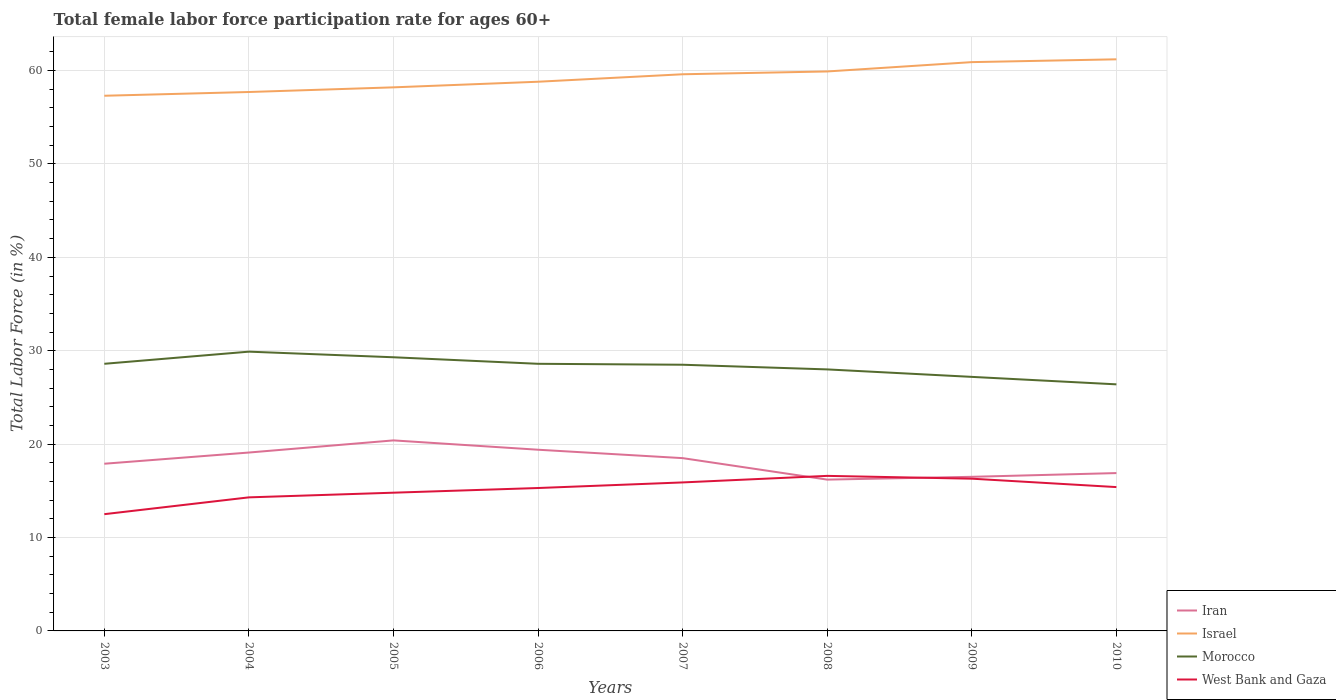How many different coloured lines are there?
Offer a very short reply. 4. Across all years, what is the maximum female labor force participation rate in Iran?
Your response must be concise. 16.2. In which year was the female labor force participation rate in Iran maximum?
Ensure brevity in your answer.  2008. What is the difference between the highest and the second highest female labor force participation rate in Iran?
Offer a terse response. 4.2. What is the difference between the highest and the lowest female labor force participation rate in Israel?
Your response must be concise. 4. Is the female labor force participation rate in Iran strictly greater than the female labor force participation rate in Israel over the years?
Your answer should be very brief. Yes. How many years are there in the graph?
Make the answer very short. 8. What is the difference between two consecutive major ticks on the Y-axis?
Offer a terse response. 10. Does the graph contain any zero values?
Your response must be concise. No. Does the graph contain grids?
Offer a terse response. Yes. Where does the legend appear in the graph?
Provide a short and direct response. Bottom right. How are the legend labels stacked?
Your response must be concise. Vertical. What is the title of the graph?
Keep it short and to the point. Total female labor force participation rate for ages 60+. What is the label or title of the Y-axis?
Your answer should be compact. Total Labor Force (in %). What is the Total Labor Force (in %) of Iran in 2003?
Your response must be concise. 17.9. What is the Total Labor Force (in %) in Israel in 2003?
Your answer should be compact. 57.3. What is the Total Labor Force (in %) in Morocco in 2003?
Your response must be concise. 28.6. What is the Total Labor Force (in %) of West Bank and Gaza in 2003?
Ensure brevity in your answer.  12.5. What is the Total Labor Force (in %) in Iran in 2004?
Your answer should be compact. 19.1. What is the Total Labor Force (in %) of Israel in 2004?
Ensure brevity in your answer.  57.7. What is the Total Labor Force (in %) of Morocco in 2004?
Your answer should be very brief. 29.9. What is the Total Labor Force (in %) in West Bank and Gaza in 2004?
Make the answer very short. 14.3. What is the Total Labor Force (in %) of Iran in 2005?
Ensure brevity in your answer.  20.4. What is the Total Labor Force (in %) of Israel in 2005?
Give a very brief answer. 58.2. What is the Total Labor Force (in %) of Morocco in 2005?
Make the answer very short. 29.3. What is the Total Labor Force (in %) of West Bank and Gaza in 2005?
Make the answer very short. 14.8. What is the Total Labor Force (in %) in Iran in 2006?
Ensure brevity in your answer.  19.4. What is the Total Labor Force (in %) of Israel in 2006?
Your response must be concise. 58.8. What is the Total Labor Force (in %) of Morocco in 2006?
Your answer should be very brief. 28.6. What is the Total Labor Force (in %) in West Bank and Gaza in 2006?
Your answer should be very brief. 15.3. What is the Total Labor Force (in %) in Iran in 2007?
Offer a very short reply. 18.5. What is the Total Labor Force (in %) in Israel in 2007?
Make the answer very short. 59.6. What is the Total Labor Force (in %) of Morocco in 2007?
Provide a succinct answer. 28.5. What is the Total Labor Force (in %) of West Bank and Gaza in 2007?
Your response must be concise. 15.9. What is the Total Labor Force (in %) in Iran in 2008?
Your response must be concise. 16.2. What is the Total Labor Force (in %) of Israel in 2008?
Your answer should be compact. 59.9. What is the Total Labor Force (in %) in Morocco in 2008?
Keep it short and to the point. 28. What is the Total Labor Force (in %) in West Bank and Gaza in 2008?
Offer a terse response. 16.6. What is the Total Labor Force (in %) of Iran in 2009?
Provide a short and direct response. 16.5. What is the Total Labor Force (in %) of Israel in 2009?
Offer a very short reply. 60.9. What is the Total Labor Force (in %) in Morocco in 2009?
Your answer should be compact. 27.2. What is the Total Labor Force (in %) in West Bank and Gaza in 2009?
Make the answer very short. 16.3. What is the Total Labor Force (in %) in Iran in 2010?
Offer a very short reply. 16.9. What is the Total Labor Force (in %) of Israel in 2010?
Keep it short and to the point. 61.2. What is the Total Labor Force (in %) in Morocco in 2010?
Offer a very short reply. 26.4. What is the Total Labor Force (in %) of West Bank and Gaza in 2010?
Offer a terse response. 15.4. Across all years, what is the maximum Total Labor Force (in %) of Iran?
Provide a succinct answer. 20.4. Across all years, what is the maximum Total Labor Force (in %) of Israel?
Your response must be concise. 61.2. Across all years, what is the maximum Total Labor Force (in %) in Morocco?
Keep it short and to the point. 29.9. Across all years, what is the maximum Total Labor Force (in %) in West Bank and Gaza?
Your response must be concise. 16.6. Across all years, what is the minimum Total Labor Force (in %) of Iran?
Make the answer very short. 16.2. Across all years, what is the minimum Total Labor Force (in %) in Israel?
Offer a very short reply. 57.3. Across all years, what is the minimum Total Labor Force (in %) of Morocco?
Give a very brief answer. 26.4. Across all years, what is the minimum Total Labor Force (in %) of West Bank and Gaza?
Keep it short and to the point. 12.5. What is the total Total Labor Force (in %) of Iran in the graph?
Keep it short and to the point. 144.9. What is the total Total Labor Force (in %) of Israel in the graph?
Ensure brevity in your answer.  473.6. What is the total Total Labor Force (in %) of Morocco in the graph?
Provide a succinct answer. 226.5. What is the total Total Labor Force (in %) of West Bank and Gaza in the graph?
Provide a succinct answer. 121.1. What is the difference between the Total Labor Force (in %) of Morocco in 2003 and that in 2004?
Provide a succinct answer. -1.3. What is the difference between the Total Labor Force (in %) of West Bank and Gaza in 2003 and that in 2004?
Provide a succinct answer. -1.8. What is the difference between the Total Labor Force (in %) in Iran in 2003 and that in 2005?
Provide a succinct answer. -2.5. What is the difference between the Total Labor Force (in %) of Morocco in 2003 and that in 2005?
Give a very brief answer. -0.7. What is the difference between the Total Labor Force (in %) in West Bank and Gaza in 2003 and that in 2005?
Your response must be concise. -2.3. What is the difference between the Total Labor Force (in %) in Iran in 2003 and that in 2006?
Offer a terse response. -1.5. What is the difference between the Total Labor Force (in %) of Israel in 2003 and that in 2006?
Ensure brevity in your answer.  -1.5. What is the difference between the Total Labor Force (in %) in Israel in 2003 and that in 2007?
Your answer should be compact. -2.3. What is the difference between the Total Labor Force (in %) of Morocco in 2003 and that in 2007?
Your response must be concise. 0.1. What is the difference between the Total Labor Force (in %) of West Bank and Gaza in 2003 and that in 2007?
Offer a very short reply. -3.4. What is the difference between the Total Labor Force (in %) of Iran in 2003 and that in 2008?
Provide a short and direct response. 1.7. What is the difference between the Total Labor Force (in %) of Morocco in 2003 and that in 2008?
Provide a succinct answer. 0.6. What is the difference between the Total Labor Force (in %) of Iran in 2003 and that in 2009?
Make the answer very short. 1.4. What is the difference between the Total Labor Force (in %) in Israel in 2003 and that in 2010?
Make the answer very short. -3.9. What is the difference between the Total Labor Force (in %) in West Bank and Gaza in 2003 and that in 2010?
Offer a very short reply. -2.9. What is the difference between the Total Labor Force (in %) of Iran in 2004 and that in 2005?
Your answer should be very brief. -1.3. What is the difference between the Total Labor Force (in %) in Israel in 2004 and that in 2005?
Provide a succinct answer. -0.5. What is the difference between the Total Labor Force (in %) in Morocco in 2004 and that in 2005?
Your response must be concise. 0.6. What is the difference between the Total Labor Force (in %) in West Bank and Gaza in 2004 and that in 2005?
Provide a succinct answer. -0.5. What is the difference between the Total Labor Force (in %) in Israel in 2004 and that in 2006?
Provide a succinct answer. -1.1. What is the difference between the Total Labor Force (in %) in Morocco in 2004 and that in 2006?
Your answer should be compact. 1.3. What is the difference between the Total Labor Force (in %) in West Bank and Gaza in 2004 and that in 2006?
Give a very brief answer. -1. What is the difference between the Total Labor Force (in %) of Iran in 2004 and that in 2007?
Keep it short and to the point. 0.6. What is the difference between the Total Labor Force (in %) in West Bank and Gaza in 2004 and that in 2008?
Offer a very short reply. -2.3. What is the difference between the Total Labor Force (in %) of Iran in 2004 and that in 2009?
Offer a very short reply. 2.6. What is the difference between the Total Labor Force (in %) in Israel in 2004 and that in 2009?
Ensure brevity in your answer.  -3.2. What is the difference between the Total Labor Force (in %) in West Bank and Gaza in 2004 and that in 2009?
Your response must be concise. -2. What is the difference between the Total Labor Force (in %) of Morocco in 2004 and that in 2010?
Offer a very short reply. 3.5. What is the difference between the Total Labor Force (in %) of Iran in 2005 and that in 2006?
Give a very brief answer. 1. What is the difference between the Total Labor Force (in %) in Morocco in 2005 and that in 2006?
Make the answer very short. 0.7. What is the difference between the Total Labor Force (in %) of West Bank and Gaza in 2005 and that in 2006?
Give a very brief answer. -0.5. What is the difference between the Total Labor Force (in %) of Iran in 2005 and that in 2007?
Make the answer very short. 1.9. What is the difference between the Total Labor Force (in %) in Morocco in 2005 and that in 2007?
Keep it short and to the point. 0.8. What is the difference between the Total Labor Force (in %) in Iran in 2005 and that in 2008?
Keep it short and to the point. 4.2. What is the difference between the Total Labor Force (in %) of Israel in 2005 and that in 2008?
Ensure brevity in your answer.  -1.7. What is the difference between the Total Labor Force (in %) of Iran in 2005 and that in 2009?
Make the answer very short. 3.9. What is the difference between the Total Labor Force (in %) of Israel in 2005 and that in 2009?
Offer a terse response. -2.7. What is the difference between the Total Labor Force (in %) in Morocco in 2005 and that in 2009?
Give a very brief answer. 2.1. What is the difference between the Total Labor Force (in %) of West Bank and Gaza in 2005 and that in 2009?
Your answer should be very brief. -1.5. What is the difference between the Total Labor Force (in %) in Morocco in 2005 and that in 2010?
Your response must be concise. 2.9. What is the difference between the Total Labor Force (in %) in West Bank and Gaza in 2005 and that in 2010?
Offer a very short reply. -0.6. What is the difference between the Total Labor Force (in %) of Israel in 2006 and that in 2007?
Keep it short and to the point. -0.8. What is the difference between the Total Labor Force (in %) in Iran in 2006 and that in 2008?
Provide a succinct answer. 3.2. What is the difference between the Total Labor Force (in %) of Morocco in 2006 and that in 2008?
Your answer should be compact. 0.6. What is the difference between the Total Labor Force (in %) in Israel in 2006 and that in 2009?
Make the answer very short. -2.1. What is the difference between the Total Labor Force (in %) in Morocco in 2006 and that in 2009?
Your answer should be very brief. 1.4. What is the difference between the Total Labor Force (in %) in Iran in 2006 and that in 2010?
Provide a succinct answer. 2.5. What is the difference between the Total Labor Force (in %) of Israel in 2006 and that in 2010?
Your response must be concise. -2.4. What is the difference between the Total Labor Force (in %) of Iran in 2007 and that in 2008?
Provide a succinct answer. 2.3. What is the difference between the Total Labor Force (in %) of West Bank and Gaza in 2007 and that in 2009?
Keep it short and to the point. -0.4. What is the difference between the Total Labor Force (in %) of Israel in 2007 and that in 2010?
Provide a succinct answer. -1.6. What is the difference between the Total Labor Force (in %) in Iran in 2008 and that in 2009?
Offer a very short reply. -0.3. What is the difference between the Total Labor Force (in %) of Israel in 2008 and that in 2009?
Keep it short and to the point. -1. What is the difference between the Total Labor Force (in %) of Morocco in 2008 and that in 2009?
Provide a succinct answer. 0.8. What is the difference between the Total Labor Force (in %) in Iran in 2008 and that in 2010?
Offer a terse response. -0.7. What is the difference between the Total Labor Force (in %) of West Bank and Gaza in 2008 and that in 2010?
Provide a succinct answer. 1.2. What is the difference between the Total Labor Force (in %) of Iran in 2009 and that in 2010?
Ensure brevity in your answer.  -0.4. What is the difference between the Total Labor Force (in %) of Morocco in 2009 and that in 2010?
Your answer should be very brief. 0.8. What is the difference between the Total Labor Force (in %) in Iran in 2003 and the Total Labor Force (in %) in Israel in 2004?
Make the answer very short. -39.8. What is the difference between the Total Labor Force (in %) of Israel in 2003 and the Total Labor Force (in %) of Morocco in 2004?
Your answer should be very brief. 27.4. What is the difference between the Total Labor Force (in %) in Morocco in 2003 and the Total Labor Force (in %) in West Bank and Gaza in 2004?
Make the answer very short. 14.3. What is the difference between the Total Labor Force (in %) of Iran in 2003 and the Total Labor Force (in %) of Israel in 2005?
Provide a short and direct response. -40.3. What is the difference between the Total Labor Force (in %) in Iran in 2003 and the Total Labor Force (in %) in Morocco in 2005?
Offer a very short reply. -11.4. What is the difference between the Total Labor Force (in %) in Iran in 2003 and the Total Labor Force (in %) in West Bank and Gaza in 2005?
Your answer should be compact. 3.1. What is the difference between the Total Labor Force (in %) of Israel in 2003 and the Total Labor Force (in %) of West Bank and Gaza in 2005?
Ensure brevity in your answer.  42.5. What is the difference between the Total Labor Force (in %) of Morocco in 2003 and the Total Labor Force (in %) of West Bank and Gaza in 2005?
Offer a very short reply. 13.8. What is the difference between the Total Labor Force (in %) of Iran in 2003 and the Total Labor Force (in %) of Israel in 2006?
Ensure brevity in your answer.  -40.9. What is the difference between the Total Labor Force (in %) of Iran in 2003 and the Total Labor Force (in %) of Morocco in 2006?
Your answer should be very brief. -10.7. What is the difference between the Total Labor Force (in %) in Iran in 2003 and the Total Labor Force (in %) in West Bank and Gaza in 2006?
Make the answer very short. 2.6. What is the difference between the Total Labor Force (in %) of Israel in 2003 and the Total Labor Force (in %) of Morocco in 2006?
Your answer should be very brief. 28.7. What is the difference between the Total Labor Force (in %) in Morocco in 2003 and the Total Labor Force (in %) in West Bank and Gaza in 2006?
Ensure brevity in your answer.  13.3. What is the difference between the Total Labor Force (in %) of Iran in 2003 and the Total Labor Force (in %) of Israel in 2007?
Your answer should be compact. -41.7. What is the difference between the Total Labor Force (in %) of Israel in 2003 and the Total Labor Force (in %) of Morocco in 2007?
Provide a succinct answer. 28.8. What is the difference between the Total Labor Force (in %) in Israel in 2003 and the Total Labor Force (in %) in West Bank and Gaza in 2007?
Give a very brief answer. 41.4. What is the difference between the Total Labor Force (in %) of Iran in 2003 and the Total Labor Force (in %) of Israel in 2008?
Provide a succinct answer. -42. What is the difference between the Total Labor Force (in %) of Iran in 2003 and the Total Labor Force (in %) of West Bank and Gaza in 2008?
Provide a short and direct response. 1.3. What is the difference between the Total Labor Force (in %) in Israel in 2003 and the Total Labor Force (in %) in Morocco in 2008?
Ensure brevity in your answer.  29.3. What is the difference between the Total Labor Force (in %) of Israel in 2003 and the Total Labor Force (in %) of West Bank and Gaza in 2008?
Your answer should be compact. 40.7. What is the difference between the Total Labor Force (in %) in Morocco in 2003 and the Total Labor Force (in %) in West Bank and Gaza in 2008?
Your answer should be very brief. 12. What is the difference between the Total Labor Force (in %) in Iran in 2003 and the Total Labor Force (in %) in Israel in 2009?
Give a very brief answer. -43. What is the difference between the Total Labor Force (in %) in Iran in 2003 and the Total Labor Force (in %) in Morocco in 2009?
Offer a very short reply. -9.3. What is the difference between the Total Labor Force (in %) in Israel in 2003 and the Total Labor Force (in %) in Morocco in 2009?
Keep it short and to the point. 30.1. What is the difference between the Total Labor Force (in %) of Morocco in 2003 and the Total Labor Force (in %) of West Bank and Gaza in 2009?
Provide a succinct answer. 12.3. What is the difference between the Total Labor Force (in %) of Iran in 2003 and the Total Labor Force (in %) of Israel in 2010?
Give a very brief answer. -43.3. What is the difference between the Total Labor Force (in %) in Iran in 2003 and the Total Labor Force (in %) in West Bank and Gaza in 2010?
Provide a short and direct response. 2.5. What is the difference between the Total Labor Force (in %) of Israel in 2003 and the Total Labor Force (in %) of Morocco in 2010?
Your answer should be very brief. 30.9. What is the difference between the Total Labor Force (in %) in Israel in 2003 and the Total Labor Force (in %) in West Bank and Gaza in 2010?
Ensure brevity in your answer.  41.9. What is the difference between the Total Labor Force (in %) of Morocco in 2003 and the Total Labor Force (in %) of West Bank and Gaza in 2010?
Your answer should be compact. 13.2. What is the difference between the Total Labor Force (in %) of Iran in 2004 and the Total Labor Force (in %) of Israel in 2005?
Offer a very short reply. -39.1. What is the difference between the Total Labor Force (in %) of Iran in 2004 and the Total Labor Force (in %) of West Bank and Gaza in 2005?
Ensure brevity in your answer.  4.3. What is the difference between the Total Labor Force (in %) of Israel in 2004 and the Total Labor Force (in %) of Morocco in 2005?
Provide a succinct answer. 28.4. What is the difference between the Total Labor Force (in %) in Israel in 2004 and the Total Labor Force (in %) in West Bank and Gaza in 2005?
Keep it short and to the point. 42.9. What is the difference between the Total Labor Force (in %) of Morocco in 2004 and the Total Labor Force (in %) of West Bank and Gaza in 2005?
Keep it short and to the point. 15.1. What is the difference between the Total Labor Force (in %) in Iran in 2004 and the Total Labor Force (in %) in Israel in 2006?
Keep it short and to the point. -39.7. What is the difference between the Total Labor Force (in %) in Iran in 2004 and the Total Labor Force (in %) in Morocco in 2006?
Ensure brevity in your answer.  -9.5. What is the difference between the Total Labor Force (in %) of Israel in 2004 and the Total Labor Force (in %) of Morocco in 2006?
Your answer should be compact. 29.1. What is the difference between the Total Labor Force (in %) in Israel in 2004 and the Total Labor Force (in %) in West Bank and Gaza in 2006?
Your answer should be compact. 42.4. What is the difference between the Total Labor Force (in %) in Morocco in 2004 and the Total Labor Force (in %) in West Bank and Gaza in 2006?
Offer a terse response. 14.6. What is the difference between the Total Labor Force (in %) in Iran in 2004 and the Total Labor Force (in %) in Israel in 2007?
Offer a very short reply. -40.5. What is the difference between the Total Labor Force (in %) of Iran in 2004 and the Total Labor Force (in %) of West Bank and Gaza in 2007?
Offer a very short reply. 3.2. What is the difference between the Total Labor Force (in %) in Israel in 2004 and the Total Labor Force (in %) in Morocco in 2007?
Your answer should be compact. 29.2. What is the difference between the Total Labor Force (in %) of Israel in 2004 and the Total Labor Force (in %) of West Bank and Gaza in 2007?
Make the answer very short. 41.8. What is the difference between the Total Labor Force (in %) of Morocco in 2004 and the Total Labor Force (in %) of West Bank and Gaza in 2007?
Offer a very short reply. 14. What is the difference between the Total Labor Force (in %) in Iran in 2004 and the Total Labor Force (in %) in Israel in 2008?
Your answer should be very brief. -40.8. What is the difference between the Total Labor Force (in %) in Iran in 2004 and the Total Labor Force (in %) in Morocco in 2008?
Keep it short and to the point. -8.9. What is the difference between the Total Labor Force (in %) of Israel in 2004 and the Total Labor Force (in %) of Morocco in 2008?
Offer a very short reply. 29.7. What is the difference between the Total Labor Force (in %) in Israel in 2004 and the Total Labor Force (in %) in West Bank and Gaza in 2008?
Give a very brief answer. 41.1. What is the difference between the Total Labor Force (in %) of Morocco in 2004 and the Total Labor Force (in %) of West Bank and Gaza in 2008?
Offer a very short reply. 13.3. What is the difference between the Total Labor Force (in %) of Iran in 2004 and the Total Labor Force (in %) of Israel in 2009?
Your response must be concise. -41.8. What is the difference between the Total Labor Force (in %) in Iran in 2004 and the Total Labor Force (in %) in Morocco in 2009?
Your answer should be very brief. -8.1. What is the difference between the Total Labor Force (in %) in Israel in 2004 and the Total Labor Force (in %) in Morocco in 2009?
Your answer should be very brief. 30.5. What is the difference between the Total Labor Force (in %) of Israel in 2004 and the Total Labor Force (in %) of West Bank and Gaza in 2009?
Offer a terse response. 41.4. What is the difference between the Total Labor Force (in %) of Morocco in 2004 and the Total Labor Force (in %) of West Bank and Gaza in 2009?
Provide a short and direct response. 13.6. What is the difference between the Total Labor Force (in %) in Iran in 2004 and the Total Labor Force (in %) in Israel in 2010?
Your response must be concise. -42.1. What is the difference between the Total Labor Force (in %) in Iran in 2004 and the Total Labor Force (in %) in Morocco in 2010?
Offer a very short reply. -7.3. What is the difference between the Total Labor Force (in %) of Iran in 2004 and the Total Labor Force (in %) of West Bank and Gaza in 2010?
Provide a succinct answer. 3.7. What is the difference between the Total Labor Force (in %) in Israel in 2004 and the Total Labor Force (in %) in Morocco in 2010?
Keep it short and to the point. 31.3. What is the difference between the Total Labor Force (in %) of Israel in 2004 and the Total Labor Force (in %) of West Bank and Gaza in 2010?
Ensure brevity in your answer.  42.3. What is the difference between the Total Labor Force (in %) of Morocco in 2004 and the Total Labor Force (in %) of West Bank and Gaza in 2010?
Offer a terse response. 14.5. What is the difference between the Total Labor Force (in %) of Iran in 2005 and the Total Labor Force (in %) of Israel in 2006?
Your answer should be compact. -38.4. What is the difference between the Total Labor Force (in %) of Iran in 2005 and the Total Labor Force (in %) of Morocco in 2006?
Provide a succinct answer. -8.2. What is the difference between the Total Labor Force (in %) in Iran in 2005 and the Total Labor Force (in %) in West Bank and Gaza in 2006?
Offer a terse response. 5.1. What is the difference between the Total Labor Force (in %) of Israel in 2005 and the Total Labor Force (in %) of Morocco in 2006?
Give a very brief answer. 29.6. What is the difference between the Total Labor Force (in %) in Israel in 2005 and the Total Labor Force (in %) in West Bank and Gaza in 2006?
Offer a very short reply. 42.9. What is the difference between the Total Labor Force (in %) in Morocco in 2005 and the Total Labor Force (in %) in West Bank and Gaza in 2006?
Provide a succinct answer. 14. What is the difference between the Total Labor Force (in %) of Iran in 2005 and the Total Labor Force (in %) of Israel in 2007?
Give a very brief answer. -39.2. What is the difference between the Total Labor Force (in %) in Israel in 2005 and the Total Labor Force (in %) in Morocco in 2007?
Offer a very short reply. 29.7. What is the difference between the Total Labor Force (in %) in Israel in 2005 and the Total Labor Force (in %) in West Bank and Gaza in 2007?
Provide a succinct answer. 42.3. What is the difference between the Total Labor Force (in %) in Iran in 2005 and the Total Labor Force (in %) in Israel in 2008?
Ensure brevity in your answer.  -39.5. What is the difference between the Total Labor Force (in %) in Iran in 2005 and the Total Labor Force (in %) in West Bank and Gaza in 2008?
Provide a short and direct response. 3.8. What is the difference between the Total Labor Force (in %) of Israel in 2005 and the Total Labor Force (in %) of Morocco in 2008?
Keep it short and to the point. 30.2. What is the difference between the Total Labor Force (in %) of Israel in 2005 and the Total Labor Force (in %) of West Bank and Gaza in 2008?
Provide a succinct answer. 41.6. What is the difference between the Total Labor Force (in %) of Iran in 2005 and the Total Labor Force (in %) of Israel in 2009?
Make the answer very short. -40.5. What is the difference between the Total Labor Force (in %) of Israel in 2005 and the Total Labor Force (in %) of Morocco in 2009?
Your answer should be very brief. 31. What is the difference between the Total Labor Force (in %) in Israel in 2005 and the Total Labor Force (in %) in West Bank and Gaza in 2009?
Ensure brevity in your answer.  41.9. What is the difference between the Total Labor Force (in %) in Iran in 2005 and the Total Labor Force (in %) in Israel in 2010?
Your response must be concise. -40.8. What is the difference between the Total Labor Force (in %) of Israel in 2005 and the Total Labor Force (in %) of Morocco in 2010?
Make the answer very short. 31.8. What is the difference between the Total Labor Force (in %) in Israel in 2005 and the Total Labor Force (in %) in West Bank and Gaza in 2010?
Your response must be concise. 42.8. What is the difference between the Total Labor Force (in %) in Iran in 2006 and the Total Labor Force (in %) in Israel in 2007?
Your answer should be compact. -40.2. What is the difference between the Total Labor Force (in %) in Israel in 2006 and the Total Labor Force (in %) in Morocco in 2007?
Offer a very short reply. 30.3. What is the difference between the Total Labor Force (in %) of Israel in 2006 and the Total Labor Force (in %) of West Bank and Gaza in 2007?
Make the answer very short. 42.9. What is the difference between the Total Labor Force (in %) of Iran in 2006 and the Total Labor Force (in %) of Israel in 2008?
Give a very brief answer. -40.5. What is the difference between the Total Labor Force (in %) in Iran in 2006 and the Total Labor Force (in %) in West Bank and Gaza in 2008?
Offer a terse response. 2.8. What is the difference between the Total Labor Force (in %) in Israel in 2006 and the Total Labor Force (in %) in Morocco in 2008?
Offer a very short reply. 30.8. What is the difference between the Total Labor Force (in %) in Israel in 2006 and the Total Labor Force (in %) in West Bank and Gaza in 2008?
Your answer should be very brief. 42.2. What is the difference between the Total Labor Force (in %) of Iran in 2006 and the Total Labor Force (in %) of Israel in 2009?
Your answer should be very brief. -41.5. What is the difference between the Total Labor Force (in %) in Israel in 2006 and the Total Labor Force (in %) in Morocco in 2009?
Ensure brevity in your answer.  31.6. What is the difference between the Total Labor Force (in %) of Israel in 2006 and the Total Labor Force (in %) of West Bank and Gaza in 2009?
Your answer should be very brief. 42.5. What is the difference between the Total Labor Force (in %) of Morocco in 2006 and the Total Labor Force (in %) of West Bank and Gaza in 2009?
Offer a very short reply. 12.3. What is the difference between the Total Labor Force (in %) in Iran in 2006 and the Total Labor Force (in %) in Israel in 2010?
Your answer should be very brief. -41.8. What is the difference between the Total Labor Force (in %) of Iran in 2006 and the Total Labor Force (in %) of Morocco in 2010?
Your answer should be compact. -7. What is the difference between the Total Labor Force (in %) of Israel in 2006 and the Total Labor Force (in %) of Morocco in 2010?
Make the answer very short. 32.4. What is the difference between the Total Labor Force (in %) of Israel in 2006 and the Total Labor Force (in %) of West Bank and Gaza in 2010?
Your response must be concise. 43.4. What is the difference between the Total Labor Force (in %) of Morocco in 2006 and the Total Labor Force (in %) of West Bank and Gaza in 2010?
Offer a very short reply. 13.2. What is the difference between the Total Labor Force (in %) of Iran in 2007 and the Total Labor Force (in %) of Israel in 2008?
Offer a very short reply. -41.4. What is the difference between the Total Labor Force (in %) in Iran in 2007 and the Total Labor Force (in %) in West Bank and Gaza in 2008?
Provide a short and direct response. 1.9. What is the difference between the Total Labor Force (in %) of Israel in 2007 and the Total Labor Force (in %) of Morocco in 2008?
Your answer should be compact. 31.6. What is the difference between the Total Labor Force (in %) in Iran in 2007 and the Total Labor Force (in %) in Israel in 2009?
Your answer should be compact. -42.4. What is the difference between the Total Labor Force (in %) of Iran in 2007 and the Total Labor Force (in %) of West Bank and Gaza in 2009?
Provide a short and direct response. 2.2. What is the difference between the Total Labor Force (in %) in Israel in 2007 and the Total Labor Force (in %) in Morocco in 2009?
Your answer should be compact. 32.4. What is the difference between the Total Labor Force (in %) of Israel in 2007 and the Total Labor Force (in %) of West Bank and Gaza in 2009?
Your answer should be compact. 43.3. What is the difference between the Total Labor Force (in %) in Iran in 2007 and the Total Labor Force (in %) in Israel in 2010?
Offer a very short reply. -42.7. What is the difference between the Total Labor Force (in %) of Israel in 2007 and the Total Labor Force (in %) of Morocco in 2010?
Give a very brief answer. 33.2. What is the difference between the Total Labor Force (in %) in Israel in 2007 and the Total Labor Force (in %) in West Bank and Gaza in 2010?
Provide a short and direct response. 44.2. What is the difference between the Total Labor Force (in %) of Iran in 2008 and the Total Labor Force (in %) of Israel in 2009?
Ensure brevity in your answer.  -44.7. What is the difference between the Total Labor Force (in %) in Iran in 2008 and the Total Labor Force (in %) in Morocco in 2009?
Ensure brevity in your answer.  -11. What is the difference between the Total Labor Force (in %) of Israel in 2008 and the Total Labor Force (in %) of Morocco in 2009?
Make the answer very short. 32.7. What is the difference between the Total Labor Force (in %) of Israel in 2008 and the Total Labor Force (in %) of West Bank and Gaza in 2009?
Provide a short and direct response. 43.6. What is the difference between the Total Labor Force (in %) of Iran in 2008 and the Total Labor Force (in %) of Israel in 2010?
Your answer should be compact. -45. What is the difference between the Total Labor Force (in %) of Iran in 2008 and the Total Labor Force (in %) of Morocco in 2010?
Offer a very short reply. -10.2. What is the difference between the Total Labor Force (in %) of Israel in 2008 and the Total Labor Force (in %) of Morocco in 2010?
Make the answer very short. 33.5. What is the difference between the Total Labor Force (in %) in Israel in 2008 and the Total Labor Force (in %) in West Bank and Gaza in 2010?
Provide a short and direct response. 44.5. What is the difference between the Total Labor Force (in %) in Morocco in 2008 and the Total Labor Force (in %) in West Bank and Gaza in 2010?
Give a very brief answer. 12.6. What is the difference between the Total Labor Force (in %) of Iran in 2009 and the Total Labor Force (in %) of Israel in 2010?
Ensure brevity in your answer.  -44.7. What is the difference between the Total Labor Force (in %) in Israel in 2009 and the Total Labor Force (in %) in Morocco in 2010?
Your answer should be very brief. 34.5. What is the difference between the Total Labor Force (in %) in Israel in 2009 and the Total Labor Force (in %) in West Bank and Gaza in 2010?
Give a very brief answer. 45.5. What is the difference between the Total Labor Force (in %) in Morocco in 2009 and the Total Labor Force (in %) in West Bank and Gaza in 2010?
Your response must be concise. 11.8. What is the average Total Labor Force (in %) of Iran per year?
Your answer should be compact. 18.11. What is the average Total Labor Force (in %) in Israel per year?
Give a very brief answer. 59.2. What is the average Total Labor Force (in %) of Morocco per year?
Your answer should be very brief. 28.31. What is the average Total Labor Force (in %) in West Bank and Gaza per year?
Offer a terse response. 15.14. In the year 2003, what is the difference between the Total Labor Force (in %) in Iran and Total Labor Force (in %) in Israel?
Provide a succinct answer. -39.4. In the year 2003, what is the difference between the Total Labor Force (in %) in Israel and Total Labor Force (in %) in Morocco?
Ensure brevity in your answer.  28.7. In the year 2003, what is the difference between the Total Labor Force (in %) in Israel and Total Labor Force (in %) in West Bank and Gaza?
Your answer should be very brief. 44.8. In the year 2004, what is the difference between the Total Labor Force (in %) of Iran and Total Labor Force (in %) of Israel?
Your answer should be compact. -38.6. In the year 2004, what is the difference between the Total Labor Force (in %) in Israel and Total Labor Force (in %) in Morocco?
Provide a short and direct response. 27.8. In the year 2004, what is the difference between the Total Labor Force (in %) of Israel and Total Labor Force (in %) of West Bank and Gaza?
Keep it short and to the point. 43.4. In the year 2004, what is the difference between the Total Labor Force (in %) in Morocco and Total Labor Force (in %) in West Bank and Gaza?
Provide a short and direct response. 15.6. In the year 2005, what is the difference between the Total Labor Force (in %) in Iran and Total Labor Force (in %) in Israel?
Provide a succinct answer. -37.8. In the year 2005, what is the difference between the Total Labor Force (in %) of Iran and Total Labor Force (in %) of Morocco?
Offer a very short reply. -8.9. In the year 2005, what is the difference between the Total Labor Force (in %) in Iran and Total Labor Force (in %) in West Bank and Gaza?
Provide a short and direct response. 5.6. In the year 2005, what is the difference between the Total Labor Force (in %) in Israel and Total Labor Force (in %) in Morocco?
Give a very brief answer. 28.9. In the year 2005, what is the difference between the Total Labor Force (in %) in Israel and Total Labor Force (in %) in West Bank and Gaza?
Offer a very short reply. 43.4. In the year 2005, what is the difference between the Total Labor Force (in %) in Morocco and Total Labor Force (in %) in West Bank and Gaza?
Your answer should be very brief. 14.5. In the year 2006, what is the difference between the Total Labor Force (in %) in Iran and Total Labor Force (in %) in Israel?
Give a very brief answer. -39.4. In the year 2006, what is the difference between the Total Labor Force (in %) in Iran and Total Labor Force (in %) in Morocco?
Offer a terse response. -9.2. In the year 2006, what is the difference between the Total Labor Force (in %) in Israel and Total Labor Force (in %) in Morocco?
Your response must be concise. 30.2. In the year 2006, what is the difference between the Total Labor Force (in %) in Israel and Total Labor Force (in %) in West Bank and Gaza?
Offer a terse response. 43.5. In the year 2006, what is the difference between the Total Labor Force (in %) of Morocco and Total Labor Force (in %) of West Bank and Gaza?
Provide a succinct answer. 13.3. In the year 2007, what is the difference between the Total Labor Force (in %) of Iran and Total Labor Force (in %) of Israel?
Ensure brevity in your answer.  -41.1. In the year 2007, what is the difference between the Total Labor Force (in %) of Israel and Total Labor Force (in %) of Morocco?
Your response must be concise. 31.1. In the year 2007, what is the difference between the Total Labor Force (in %) in Israel and Total Labor Force (in %) in West Bank and Gaza?
Provide a short and direct response. 43.7. In the year 2007, what is the difference between the Total Labor Force (in %) of Morocco and Total Labor Force (in %) of West Bank and Gaza?
Your answer should be very brief. 12.6. In the year 2008, what is the difference between the Total Labor Force (in %) of Iran and Total Labor Force (in %) of Israel?
Offer a very short reply. -43.7. In the year 2008, what is the difference between the Total Labor Force (in %) in Israel and Total Labor Force (in %) in Morocco?
Your answer should be compact. 31.9. In the year 2008, what is the difference between the Total Labor Force (in %) in Israel and Total Labor Force (in %) in West Bank and Gaza?
Give a very brief answer. 43.3. In the year 2009, what is the difference between the Total Labor Force (in %) in Iran and Total Labor Force (in %) in Israel?
Your response must be concise. -44.4. In the year 2009, what is the difference between the Total Labor Force (in %) of Israel and Total Labor Force (in %) of Morocco?
Your answer should be very brief. 33.7. In the year 2009, what is the difference between the Total Labor Force (in %) in Israel and Total Labor Force (in %) in West Bank and Gaza?
Your answer should be very brief. 44.6. In the year 2010, what is the difference between the Total Labor Force (in %) in Iran and Total Labor Force (in %) in Israel?
Keep it short and to the point. -44.3. In the year 2010, what is the difference between the Total Labor Force (in %) of Iran and Total Labor Force (in %) of West Bank and Gaza?
Make the answer very short. 1.5. In the year 2010, what is the difference between the Total Labor Force (in %) of Israel and Total Labor Force (in %) of Morocco?
Ensure brevity in your answer.  34.8. In the year 2010, what is the difference between the Total Labor Force (in %) of Israel and Total Labor Force (in %) of West Bank and Gaza?
Give a very brief answer. 45.8. In the year 2010, what is the difference between the Total Labor Force (in %) of Morocco and Total Labor Force (in %) of West Bank and Gaza?
Your response must be concise. 11. What is the ratio of the Total Labor Force (in %) of Iran in 2003 to that in 2004?
Provide a succinct answer. 0.94. What is the ratio of the Total Labor Force (in %) of Israel in 2003 to that in 2004?
Your answer should be very brief. 0.99. What is the ratio of the Total Labor Force (in %) of Morocco in 2003 to that in 2004?
Provide a short and direct response. 0.96. What is the ratio of the Total Labor Force (in %) in West Bank and Gaza in 2003 to that in 2004?
Make the answer very short. 0.87. What is the ratio of the Total Labor Force (in %) of Iran in 2003 to that in 2005?
Offer a very short reply. 0.88. What is the ratio of the Total Labor Force (in %) in Israel in 2003 to that in 2005?
Your response must be concise. 0.98. What is the ratio of the Total Labor Force (in %) of Morocco in 2003 to that in 2005?
Offer a terse response. 0.98. What is the ratio of the Total Labor Force (in %) in West Bank and Gaza in 2003 to that in 2005?
Ensure brevity in your answer.  0.84. What is the ratio of the Total Labor Force (in %) of Iran in 2003 to that in 2006?
Offer a terse response. 0.92. What is the ratio of the Total Labor Force (in %) of Israel in 2003 to that in 2006?
Offer a very short reply. 0.97. What is the ratio of the Total Labor Force (in %) in Morocco in 2003 to that in 2006?
Your answer should be compact. 1. What is the ratio of the Total Labor Force (in %) in West Bank and Gaza in 2003 to that in 2006?
Keep it short and to the point. 0.82. What is the ratio of the Total Labor Force (in %) of Iran in 2003 to that in 2007?
Offer a terse response. 0.97. What is the ratio of the Total Labor Force (in %) in Israel in 2003 to that in 2007?
Give a very brief answer. 0.96. What is the ratio of the Total Labor Force (in %) in Morocco in 2003 to that in 2007?
Provide a short and direct response. 1. What is the ratio of the Total Labor Force (in %) in West Bank and Gaza in 2003 to that in 2007?
Give a very brief answer. 0.79. What is the ratio of the Total Labor Force (in %) of Iran in 2003 to that in 2008?
Offer a terse response. 1.1. What is the ratio of the Total Labor Force (in %) of Israel in 2003 to that in 2008?
Your answer should be compact. 0.96. What is the ratio of the Total Labor Force (in %) in Morocco in 2003 to that in 2008?
Ensure brevity in your answer.  1.02. What is the ratio of the Total Labor Force (in %) in West Bank and Gaza in 2003 to that in 2008?
Your answer should be very brief. 0.75. What is the ratio of the Total Labor Force (in %) of Iran in 2003 to that in 2009?
Give a very brief answer. 1.08. What is the ratio of the Total Labor Force (in %) of Israel in 2003 to that in 2009?
Your answer should be compact. 0.94. What is the ratio of the Total Labor Force (in %) of Morocco in 2003 to that in 2009?
Ensure brevity in your answer.  1.05. What is the ratio of the Total Labor Force (in %) of West Bank and Gaza in 2003 to that in 2009?
Make the answer very short. 0.77. What is the ratio of the Total Labor Force (in %) of Iran in 2003 to that in 2010?
Your answer should be very brief. 1.06. What is the ratio of the Total Labor Force (in %) in Israel in 2003 to that in 2010?
Give a very brief answer. 0.94. What is the ratio of the Total Labor Force (in %) of Morocco in 2003 to that in 2010?
Provide a succinct answer. 1.08. What is the ratio of the Total Labor Force (in %) of West Bank and Gaza in 2003 to that in 2010?
Your answer should be very brief. 0.81. What is the ratio of the Total Labor Force (in %) in Iran in 2004 to that in 2005?
Give a very brief answer. 0.94. What is the ratio of the Total Labor Force (in %) in Israel in 2004 to that in 2005?
Offer a terse response. 0.99. What is the ratio of the Total Labor Force (in %) in Morocco in 2004 to that in 2005?
Ensure brevity in your answer.  1.02. What is the ratio of the Total Labor Force (in %) of West Bank and Gaza in 2004 to that in 2005?
Offer a very short reply. 0.97. What is the ratio of the Total Labor Force (in %) in Iran in 2004 to that in 2006?
Ensure brevity in your answer.  0.98. What is the ratio of the Total Labor Force (in %) of Israel in 2004 to that in 2006?
Keep it short and to the point. 0.98. What is the ratio of the Total Labor Force (in %) of Morocco in 2004 to that in 2006?
Offer a terse response. 1.05. What is the ratio of the Total Labor Force (in %) in West Bank and Gaza in 2004 to that in 2006?
Ensure brevity in your answer.  0.93. What is the ratio of the Total Labor Force (in %) of Iran in 2004 to that in 2007?
Keep it short and to the point. 1.03. What is the ratio of the Total Labor Force (in %) in Israel in 2004 to that in 2007?
Your answer should be compact. 0.97. What is the ratio of the Total Labor Force (in %) of Morocco in 2004 to that in 2007?
Offer a very short reply. 1.05. What is the ratio of the Total Labor Force (in %) of West Bank and Gaza in 2004 to that in 2007?
Your answer should be very brief. 0.9. What is the ratio of the Total Labor Force (in %) in Iran in 2004 to that in 2008?
Give a very brief answer. 1.18. What is the ratio of the Total Labor Force (in %) of Israel in 2004 to that in 2008?
Your answer should be very brief. 0.96. What is the ratio of the Total Labor Force (in %) in Morocco in 2004 to that in 2008?
Offer a terse response. 1.07. What is the ratio of the Total Labor Force (in %) of West Bank and Gaza in 2004 to that in 2008?
Offer a very short reply. 0.86. What is the ratio of the Total Labor Force (in %) in Iran in 2004 to that in 2009?
Make the answer very short. 1.16. What is the ratio of the Total Labor Force (in %) of Israel in 2004 to that in 2009?
Provide a short and direct response. 0.95. What is the ratio of the Total Labor Force (in %) of Morocco in 2004 to that in 2009?
Your answer should be very brief. 1.1. What is the ratio of the Total Labor Force (in %) in West Bank and Gaza in 2004 to that in 2009?
Provide a short and direct response. 0.88. What is the ratio of the Total Labor Force (in %) in Iran in 2004 to that in 2010?
Your answer should be very brief. 1.13. What is the ratio of the Total Labor Force (in %) of Israel in 2004 to that in 2010?
Make the answer very short. 0.94. What is the ratio of the Total Labor Force (in %) in Morocco in 2004 to that in 2010?
Offer a terse response. 1.13. What is the ratio of the Total Labor Force (in %) in Iran in 2005 to that in 2006?
Offer a terse response. 1.05. What is the ratio of the Total Labor Force (in %) in Morocco in 2005 to that in 2006?
Your response must be concise. 1.02. What is the ratio of the Total Labor Force (in %) in West Bank and Gaza in 2005 to that in 2006?
Ensure brevity in your answer.  0.97. What is the ratio of the Total Labor Force (in %) in Iran in 2005 to that in 2007?
Provide a short and direct response. 1.1. What is the ratio of the Total Labor Force (in %) in Israel in 2005 to that in 2007?
Offer a very short reply. 0.98. What is the ratio of the Total Labor Force (in %) of Morocco in 2005 to that in 2007?
Keep it short and to the point. 1.03. What is the ratio of the Total Labor Force (in %) of West Bank and Gaza in 2005 to that in 2007?
Your answer should be very brief. 0.93. What is the ratio of the Total Labor Force (in %) of Iran in 2005 to that in 2008?
Your answer should be very brief. 1.26. What is the ratio of the Total Labor Force (in %) of Israel in 2005 to that in 2008?
Your answer should be very brief. 0.97. What is the ratio of the Total Labor Force (in %) in Morocco in 2005 to that in 2008?
Your response must be concise. 1.05. What is the ratio of the Total Labor Force (in %) in West Bank and Gaza in 2005 to that in 2008?
Your answer should be very brief. 0.89. What is the ratio of the Total Labor Force (in %) of Iran in 2005 to that in 2009?
Your response must be concise. 1.24. What is the ratio of the Total Labor Force (in %) in Israel in 2005 to that in 2009?
Provide a succinct answer. 0.96. What is the ratio of the Total Labor Force (in %) of Morocco in 2005 to that in 2009?
Keep it short and to the point. 1.08. What is the ratio of the Total Labor Force (in %) of West Bank and Gaza in 2005 to that in 2009?
Give a very brief answer. 0.91. What is the ratio of the Total Labor Force (in %) in Iran in 2005 to that in 2010?
Keep it short and to the point. 1.21. What is the ratio of the Total Labor Force (in %) in Israel in 2005 to that in 2010?
Ensure brevity in your answer.  0.95. What is the ratio of the Total Labor Force (in %) in Morocco in 2005 to that in 2010?
Your answer should be very brief. 1.11. What is the ratio of the Total Labor Force (in %) of West Bank and Gaza in 2005 to that in 2010?
Your response must be concise. 0.96. What is the ratio of the Total Labor Force (in %) in Iran in 2006 to that in 2007?
Your answer should be very brief. 1.05. What is the ratio of the Total Labor Force (in %) in Israel in 2006 to that in 2007?
Offer a very short reply. 0.99. What is the ratio of the Total Labor Force (in %) of West Bank and Gaza in 2006 to that in 2007?
Your answer should be compact. 0.96. What is the ratio of the Total Labor Force (in %) of Iran in 2006 to that in 2008?
Give a very brief answer. 1.2. What is the ratio of the Total Labor Force (in %) of Israel in 2006 to that in 2008?
Make the answer very short. 0.98. What is the ratio of the Total Labor Force (in %) of Morocco in 2006 to that in 2008?
Offer a very short reply. 1.02. What is the ratio of the Total Labor Force (in %) of West Bank and Gaza in 2006 to that in 2008?
Offer a very short reply. 0.92. What is the ratio of the Total Labor Force (in %) of Iran in 2006 to that in 2009?
Offer a terse response. 1.18. What is the ratio of the Total Labor Force (in %) in Israel in 2006 to that in 2009?
Your answer should be compact. 0.97. What is the ratio of the Total Labor Force (in %) in Morocco in 2006 to that in 2009?
Make the answer very short. 1.05. What is the ratio of the Total Labor Force (in %) in West Bank and Gaza in 2006 to that in 2009?
Your answer should be very brief. 0.94. What is the ratio of the Total Labor Force (in %) of Iran in 2006 to that in 2010?
Give a very brief answer. 1.15. What is the ratio of the Total Labor Force (in %) in Israel in 2006 to that in 2010?
Offer a terse response. 0.96. What is the ratio of the Total Labor Force (in %) of Morocco in 2006 to that in 2010?
Make the answer very short. 1.08. What is the ratio of the Total Labor Force (in %) of West Bank and Gaza in 2006 to that in 2010?
Offer a terse response. 0.99. What is the ratio of the Total Labor Force (in %) of Iran in 2007 to that in 2008?
Your answer should be very brief. 1.14. What is the ratio of the Total Labor Force (in %) in Morocco in 2007 to that in 2008?
Keep it short and to the point. 1.02. What is the ratio of the Total Labor Force (in %) of West Bank and Gaza in 2007 to that in 2008?
Provide a succinct answer. 0.96. What is the ratio of the Total Labor Force (in %) of Iran in 2007 to that in 2009?
Keep it short and to the point. 1.12. What is the ratio of the Total Labor Force (in %) in Israel in 2007 to that in 2009?
Your response must be concise. 0.98. What is the ratio of the Total Labor Force (in %) in Morocco in 2007 to that in 2009?
Give a very brief answer. 1.05. What is the ratio of the Total Labor Force (in %) in West Bank and Gaza in 2007 to that in 2009?
Keep it short and to the point. 0.98. What is the ratio of the Total Labor Force (in %) in Iran in 2007 to that in 2010?
Offer a terse response. 1.09. What is the ratio of the Total Labor Force (in %) of Israel in 2007 to that in 2010?
Offer a very short reply. 0.97. What is the ratio of the Total Labor Force (in %) of Morocco in 2007 to that in 2010?
Provide a succinct answer. 1.08. What is the ratio of the Total Labor Force (in %) in West Bank and Gaza in 2007 to that in 2010?
Your response must be concise. 1.03. What is the ratio of the Total Labor Force (in %) of Iran in 2008 to that in 2009?
Your response must be concise. 0.98. What is the ratio of the Total Labor Force (in %) in Israel in 2008 to that in 2009?
Your answer should be compact. 0.98. What is the ratio of the Total Labor Force (in %) in Morocco in 2008 to that in 2009?
Provide a succinct answer. 1.03. What is the ratio of the Total Labor Force (in %) of West Bank and Gaza in 2008 to that in 2009?
Offer a terse response. 1.02. What is the ratio of the Total Labor Force (in %) in Iran in 2008 to that in 2010?
Your response must be concise. 0.96. What is the ratio of the Total Labor Force (in %) of Israel in 2008 to that in 2010?
Ensure brevity in your answer.  0.98. What is the ratio of the Total Labor Force (in %) in Morocco in 2008 to that in 2010?
Give a very brief answer. 1.06. What is the ratio of the Total Labor Force (in %) in West Bank and Gaza in 2008 to that in 2010?
Provide a succinct answer. 1.08. What is the ratio of the Total Labor Force (in %) in Iran in 2009 to that in 2010?
Offer a terse response. 0.98. What is the ratio of the Total Labor Force (in %) of Israel in 2009 to that in 2010?
Give a very brief answer. 1. What is the ratio of the Total Labor Force (in %) of Morocco in 2009 to that in 2010?
Your response must be concise. 1.03. What is the ratio of the Total Labor Force (in %) in West Bank and Gaza in 2009 to that in 2010?
Make the answer very short. 1.06. What is the difference between the highest and the second highest Total Labor Force (in %) of Iran?
Provide a short and direct response. 1. What is the difference between the highest and the second highest Total Labor Force (in %) in Morocco?
Provide a succinct answer. 0.6. What is the difference between the highest and the lowest Total Labor Force (in %) of Israel?
Your answer should be very brief. 3.9. What is the difference between the highest and the lowest Total Labor Force (in %) of Morocco?
Offer a terse response. 3.5. What is the difference between the highest and the lowest Total Labor Force (in %) in West Bank and Gaza?
Provide a short and direct response. 4.1. 